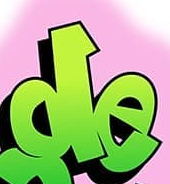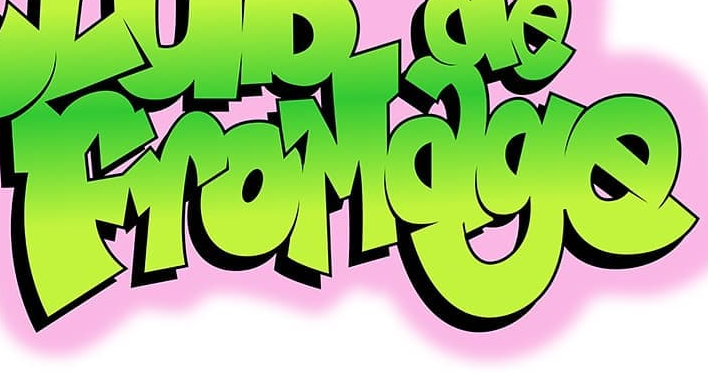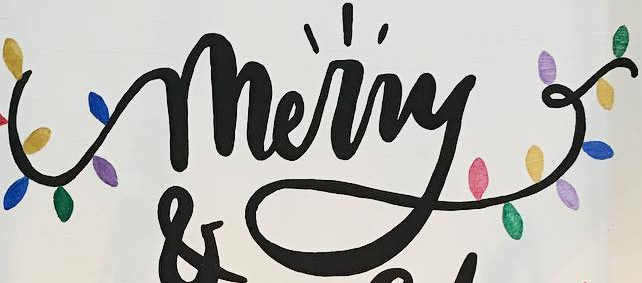Transcribe the words shown in these images in order, separated by a semicolon. de; FroMage; merry 